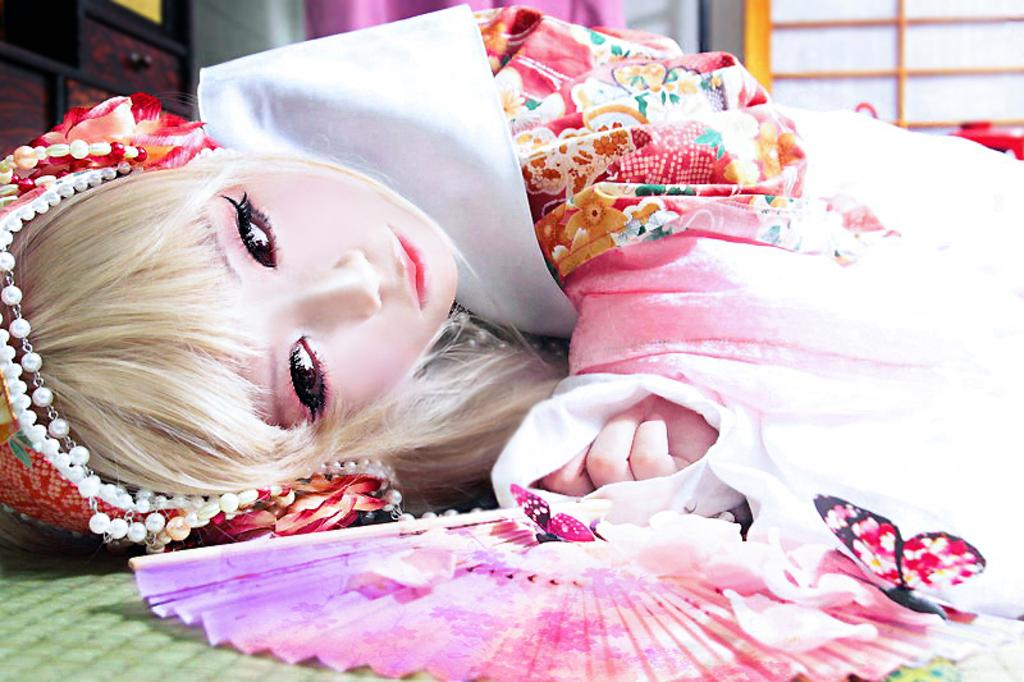Who is the main subject in the image? There is a woman in the image. What is the woman wearing? The woman is wearing a fancy dress. Where is the woman located in the image? The woman is laying on a path. What can be seen in the background of the image? There are drawers visible in the background of the image, as well as other unspecified objects. What type of corn is being used to decorate the throne in the image? There is no throne or corn present in the image; it features a woman laying on a path. What kind of bulb is illuminating the scene in the image? There is no mention of a bulb or any artificial lighting in the image; it appears to be naturally lit. 